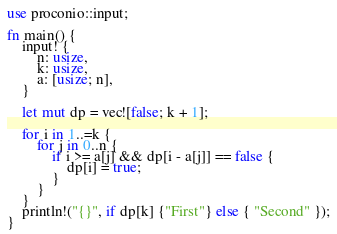Convert code to text. <code><loc_0><loc_0><loc_500><loc_500><_Rust_>use proconio::input;

fn main() {
    input! {
        n: usize,
        k: usize,
        a: [usize; n],
    }

    let mut dp = vec![false; k + 1];

    for i in 1..=k {
        for j in 0..n {
            if i >= a[j] && dp[i - a[j]] == false {
                dp[i] = true;
            }
        }
    }
    println!("{}", if dp[k] {"First"} else { "Second" });
}
</code> 